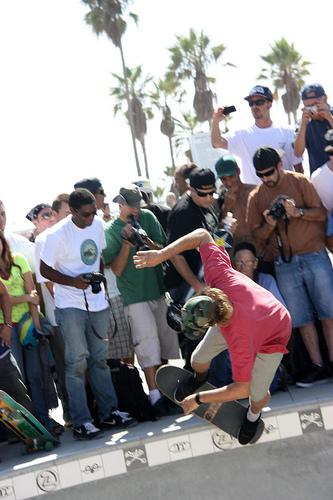Question: who are the people in the background looking at?
Choices:
A. The giraffe.
B. Skateboarder.
C. The elephant.
D. The magician.
Answer with the letter. Answer: B Question: what is the skateboarder doing?
Choices:
A. Holding the skateboard.
B. Tricks.
C. Riding the skateboard.
D. Working on his skateboard's wheels.
Answer with the letter. Answer: B Question: what are the men in the background holding in their hands?
Choices:
A. Cameras.
B. Umbrellas.
C. Flags.
D. Cellphones.
Answer with the letter. Answer: A Question: what color are the skateboarder's shorts?
Choices:
A. Blue.
B. White.
C. Black.
D. Tan.
Answer with the letter. Answer: D Question: what does the skateboarder have on his head?
Choices:
A. Scarf.
B. Helmet.
C. Cap.
D. A sweatband.
Answer with the letter. Answer: C 